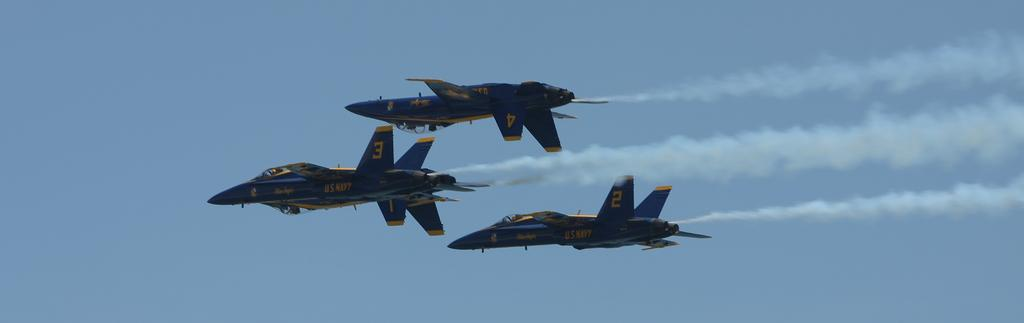What is the main subject of the image? The main subject of the image is three jet planes. Where are the jet planes located in the image? The jet planes are in the sky. How many pets can be seen on the jet planes in the image? There are no pets visible on the jet planes in the image. What type of insect is crawling on the wing of the jet plane in the image? There is no insect, such as a ladybug, present on the jet plane in the image. 